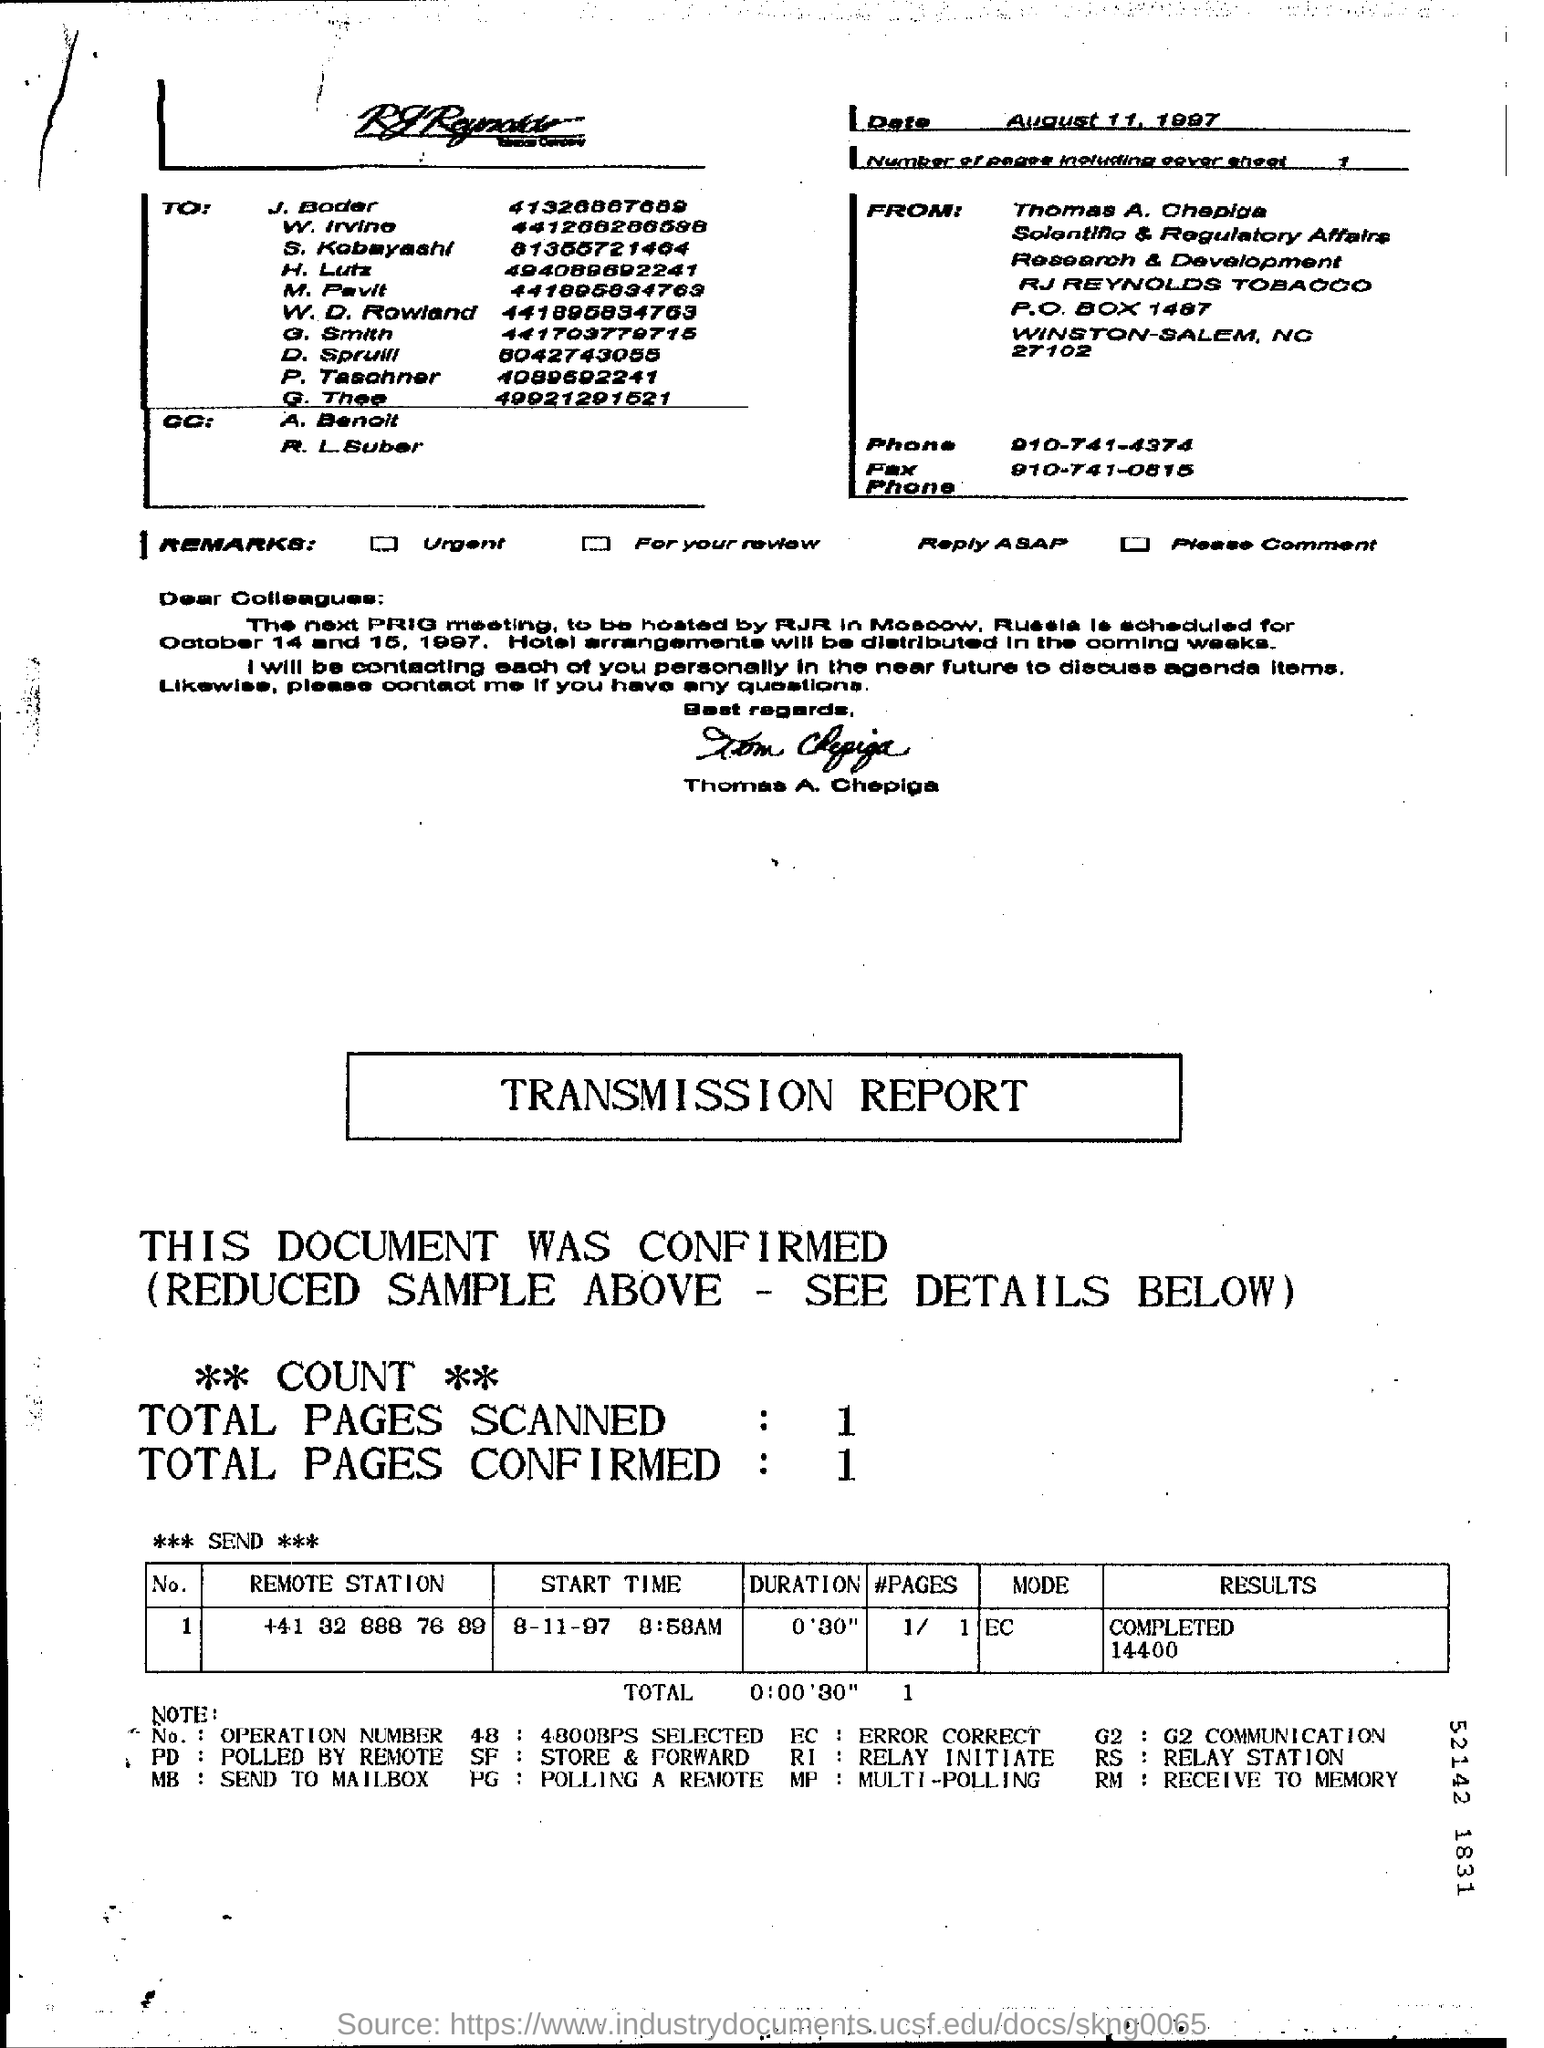Mention a couple of crucial points in this snapshot. The document is dated August 11, 1997. Please provide the remote station number, which is +41 32 888 76 89. There is one page, including the cover sheet. The location of the next PRIG meeting has been announced to be hosted by RJR, in Russia. 